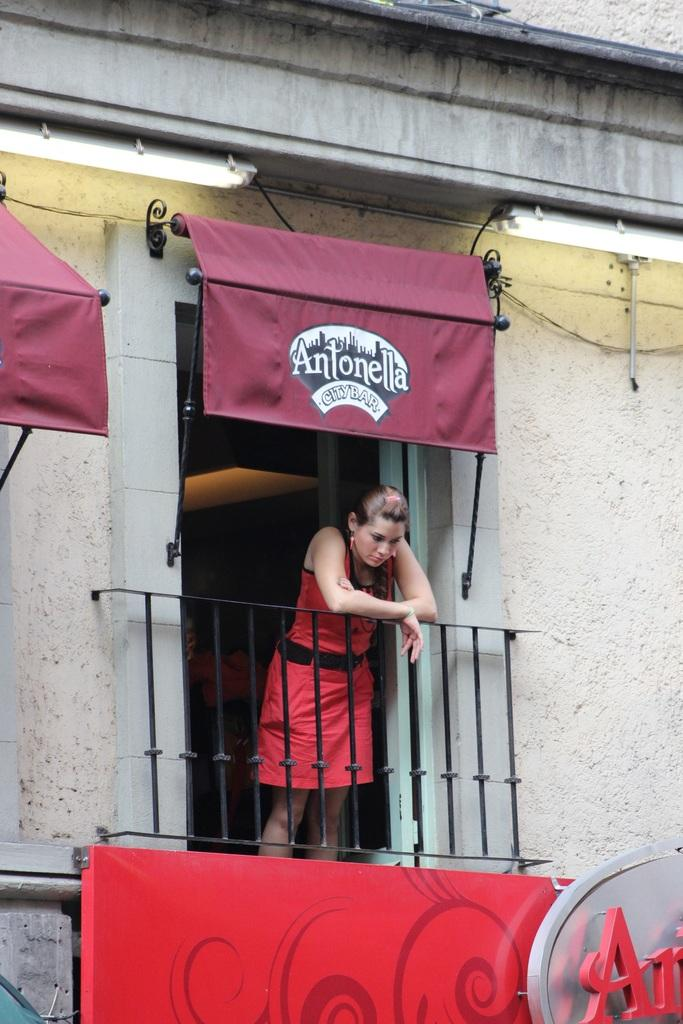Who is the main subject in the image? There is a woman in the image. What is the woman doing in the image? The woman is standing and looking down through a railing. What can be seen in the background of the image? There are buildings and a pipeline in the background of the image. What type of brake system can be seen on the pipeline in the image? There is no brake system present on the pipeline in the image. How is the division of labor represented in the image? The image does not depict any division of labor or work-related activities. 